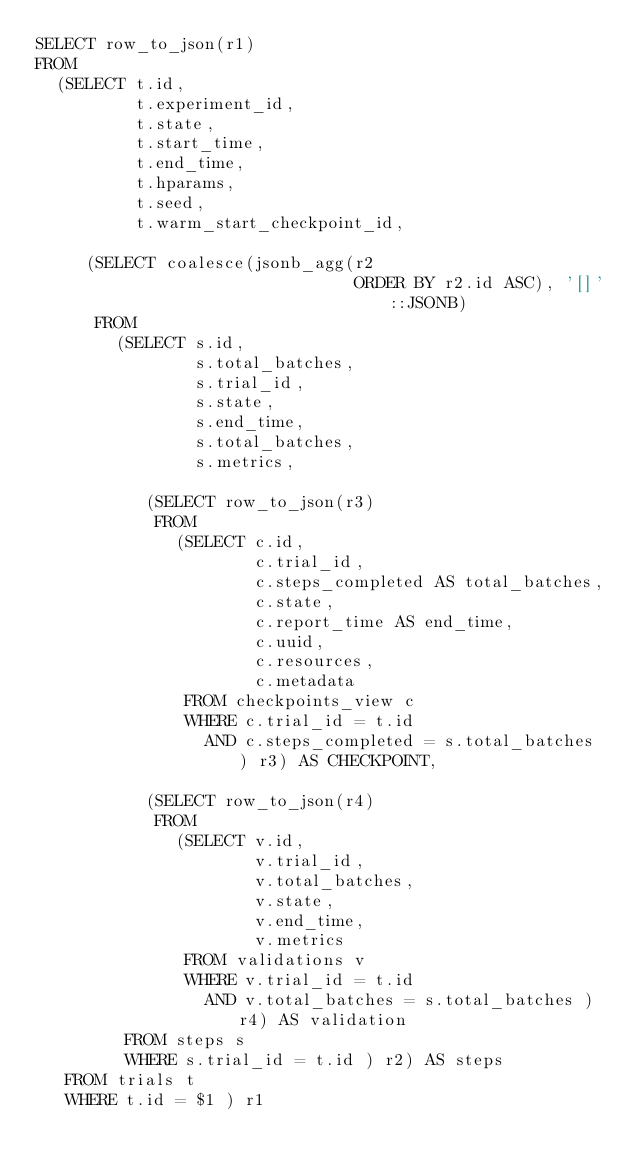Convert code to text. <code><loc_0><loc_0><loc_500><loc_500><_SQL_>SELECT row_to_json(r1)
FROM
  (SELECT t.id,
          t.experiment_id,
          t.state,
          t.start_time,
          t.end_time,
          t.hparams,
          t.seed,
          t.warm_start_checkpoint_id,

     (SELECT coalesce(jsonb_agg(r2
                                ORDER BY r2.id ASC), '[]'::JSONB)
      FROM
        (SELECT s.id,
                s.total_batches,
                s.trial_id,
                s.state,
                s.end_time,
                s.total_batches,
                s.metrics,

           (SELECT row_to_json(r3)
            FROM
              (SELECT c.id,
                      c.trial_id,
                      c.steps_completed AS total_batches,
                      c.state,
                      c.report_time AS end_time,
                      c.uuid,
                      c.resources,
                      c.metadata
               FROM checkpoints_view c
               WHERE c.trial_id = t.id
                 AND c.steps_completed = s.total_batches ) r3) AS CHECKPOINT,

           (SELECT row_to_json(r4)
            FROM
              (SELECT v.id,
                      v.trial_id,
                      v.total_batches,
                      v.state,
                      v.end_time,
                      v.metrics
               FROM validations v
               WHERE v.trial_id = t.id
                 AND v.total_batches = s.total_batches ) r4) AS validation
         FROM steps s
         WHERE s.trial_id = t.id ) r2) AS steps
   FROM trials t
   WHERE t.id = $1 ) r1
</code> 